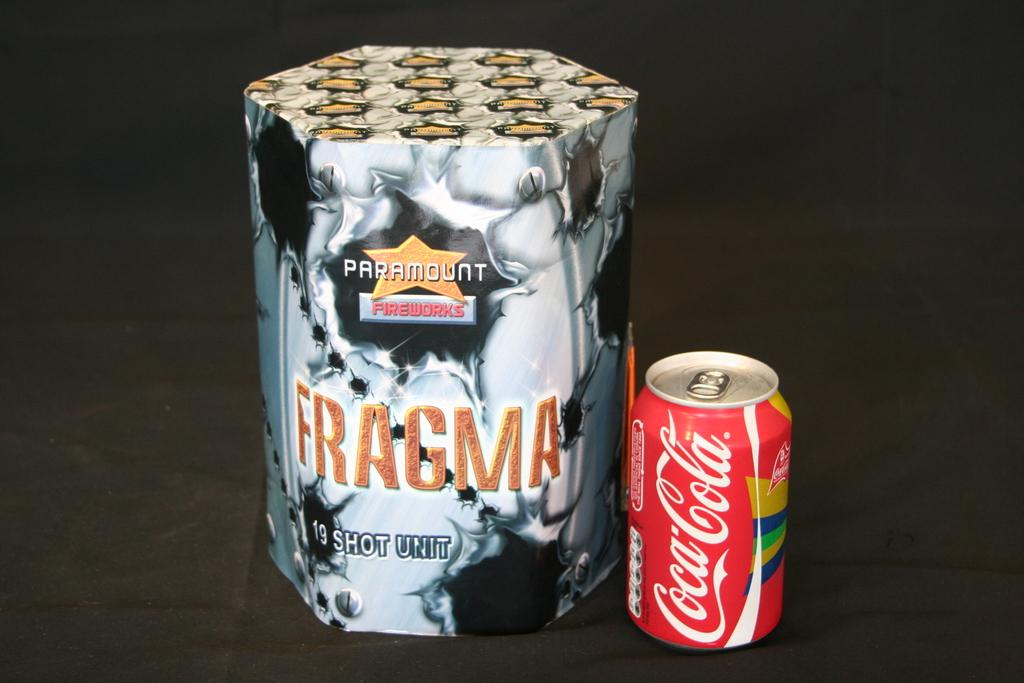<image>
Offer a succinct explanation of the picture presented. the words coca cola which is on a soda can 